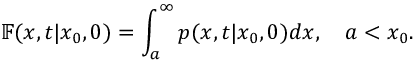<formula> <loc_0><loc_0><loc_500><loc_500>\mathbb { F } ( x , t | x _ { 0 } , 0 ) = \int _ { a } ^ { \infty } p ( x , t | x _ { 0 } , 0 ) d x , \quad a < x _ { 0 } .</formula> 